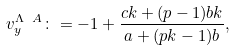Convert formula to latex. <formula><loc_0><loc_0><loc_500><loc_500>v _ { y } ^ { \Lambda \ A } \colon = - 1 + \frac { c k + ( p - 1 ) b k } { a + ( p k - 1 ) b } ,</formula> 